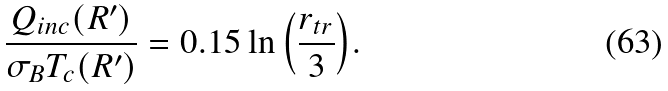Convert formula to latex. <formula><loc_0><loc_0><loc_500><loc_500>\frac { Q _ { i n c } ( R ^ { \prime } ) } { \sigma _ { B } T _ { c } ( R ^ { \prime } ) } = 0 . 1 5 \ln { \left ( \frac { r _ { t r } } { 3 } \right ) } .</formula> 